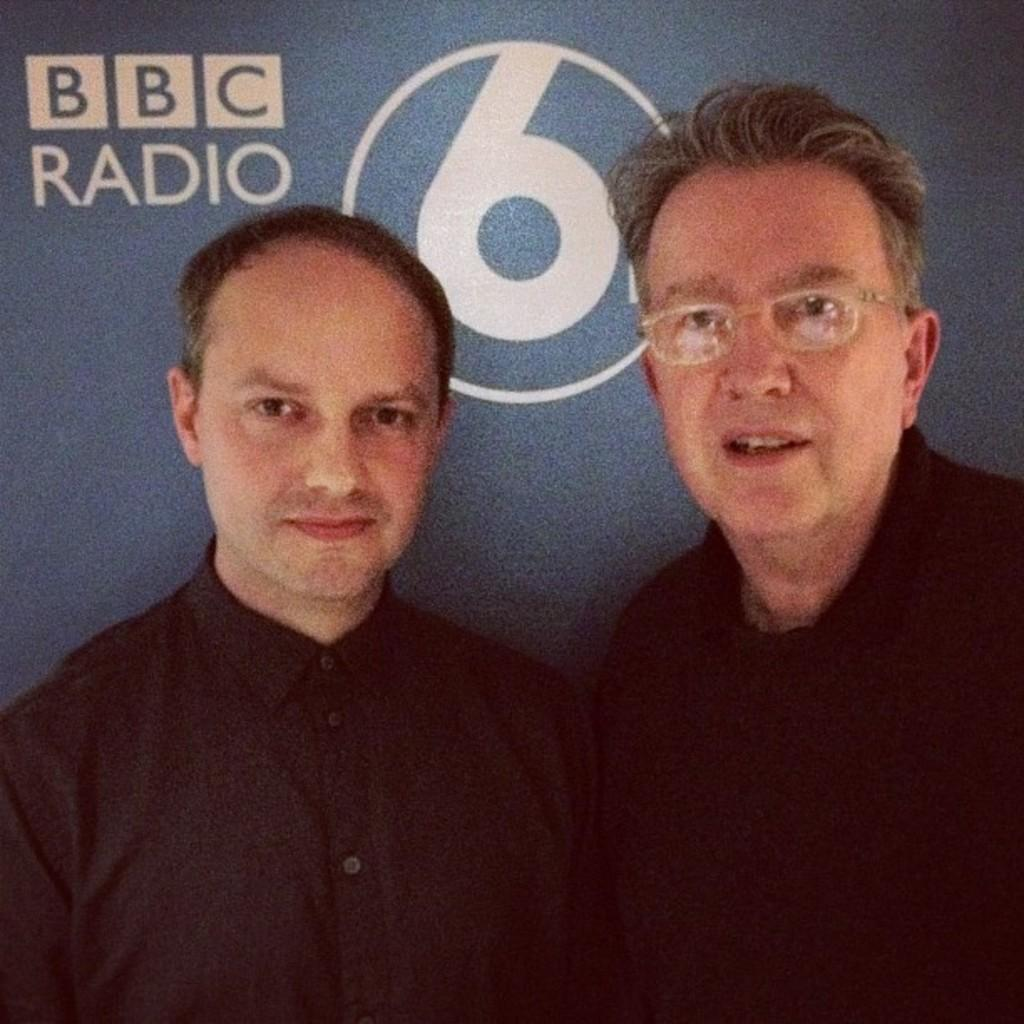How many people are in the image? There are two men in the image. What are the men wearing? The men are wearing black dress. What color is the wall in the background of the image? There is a blue wall in the background of the image. What is written on the blue wall? Something is written on the blue wall. How many geese are flying over the border in the image? There are no geese or borders present in the image. What type of passenger is sitting next to the men in the image? There are no passengers or additional people present in the image besides the two men. 